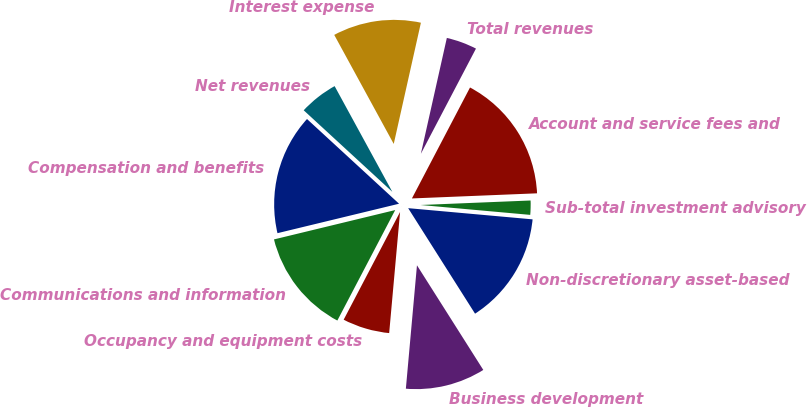Convert chart to OTSL. <chart><loc_0><loc_0><loc_500><loc_500><pie_chart><fcel>Non-discretionary asset-based<fcel>Sub-total investment advisory<fcel>Account and service fees and<fcel>Total revenues<fcel>Interest expense<fcel>Net revenues<fcel>Compensation and benefits<fcel>Communications and information<fcel>Occupancy and equipment costs<fcel>Business development<nl><fcel>14.58%<fcel>2.08%<fcel>16.67%<fcel>4.17%<fcel>11.46%<fcel>5.21%<fcel>15.62%<fcel>13.54%<fcel>6.25%<fcel>10.42%<nl></chart> 